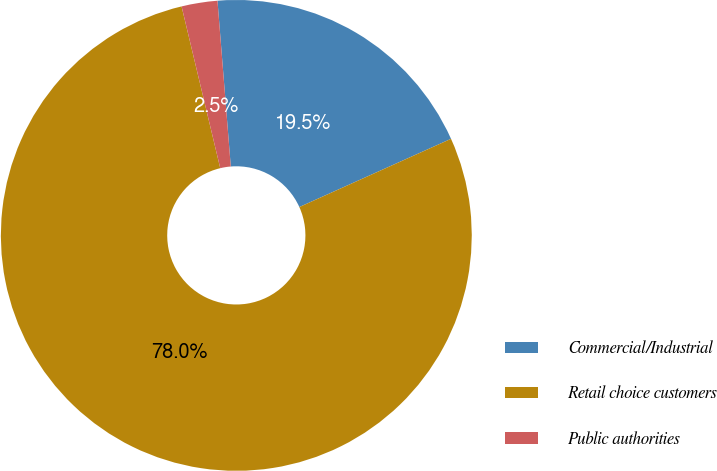Convert chart. <chart><loc_0><loc_0><loc_500><loc_500><pie_chart><fcel>Commercial/Industrial<fcel>Retail choice customers<fcel>Public authorities<nl><fcel>19.55%<fcel>78.0%<fcel>2.46%<nl></chart> 